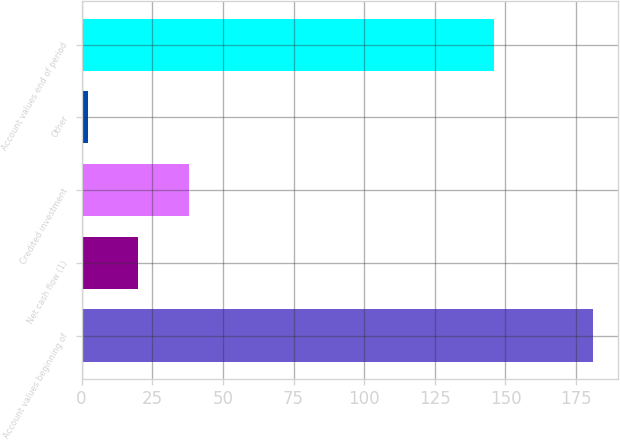<chart> <loc_0><loc_0><loc_500><loc_500><bar_chart><fcel>Account values beginning of<fcel>Net cash flow (1)<fcel>Credited investment<fcel>Other<fcel>Account values end of period<nl><fcel>180.8<fcel>19.97<fcel>37.84<fcel>2.1<fcel>146.1<nl></chart> 